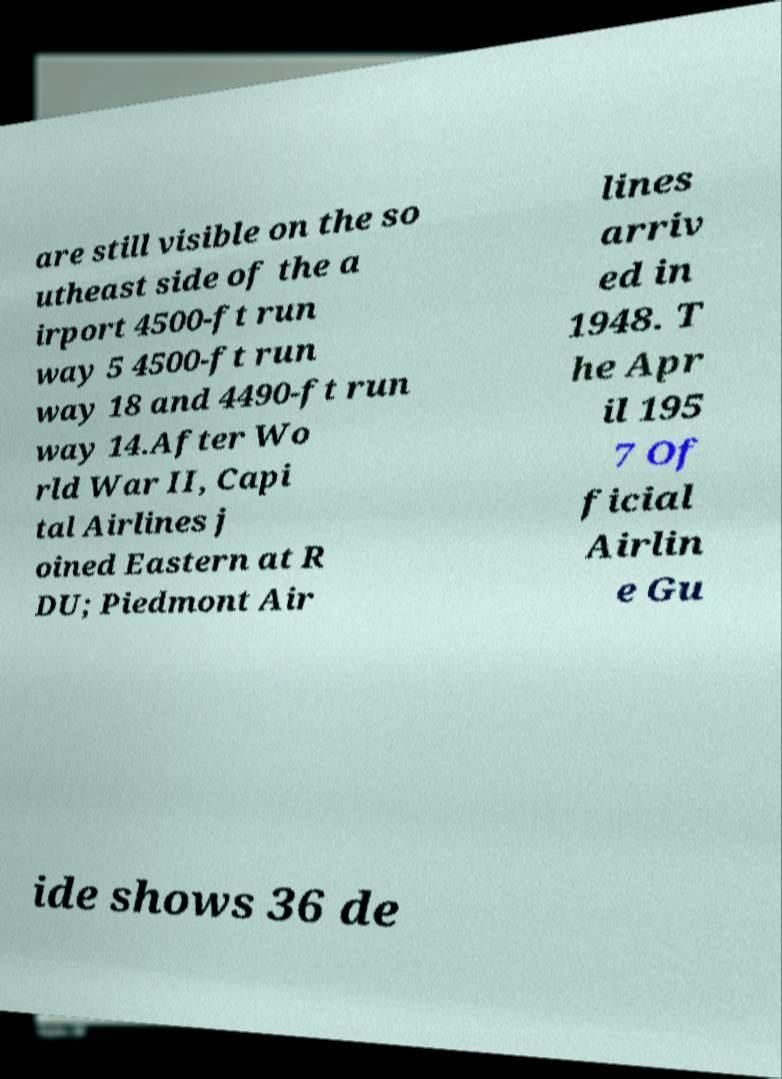There's text embedded in this image that I need extracted. Can you transcribe it verbatim? are still visible on the so utheast side of the a irport 4500-ft run way 5 4500-ft run way 18 and 4490-ft run way 14.After Wo rld War II, Capi tal Airlines j oined Eastern at R DU; Piedmont Air lines arriv ed in 1948. T he Apr il 195 7 Of ficial Airlin e Gu ide shows 36 de 